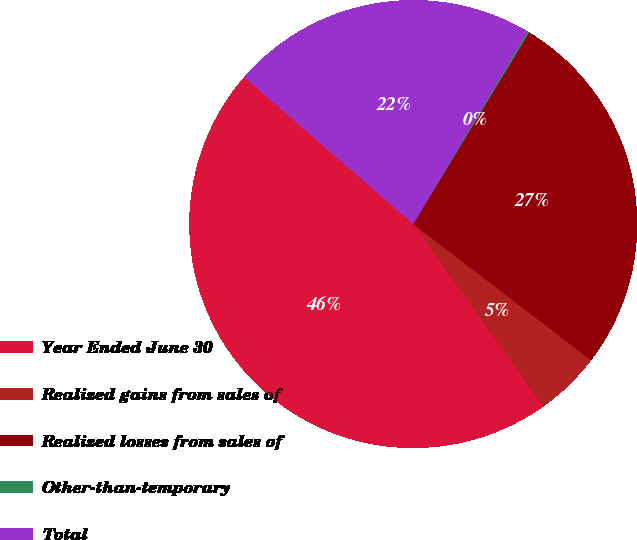Convert chart. <chart><loc_0><loc_0><loc_500><loc_500><pie_chart><fcel>Year Ended June 30<fcel>Realized gains from sales of<fcel>Realized losses from sales of<fcel>Other-than-temporary<fcel>Total<nl><fcel>46.24%<fcel>4.75%<fcel>26.74%<fcel>0.14%<fcel>22.13%<nl></chart> 